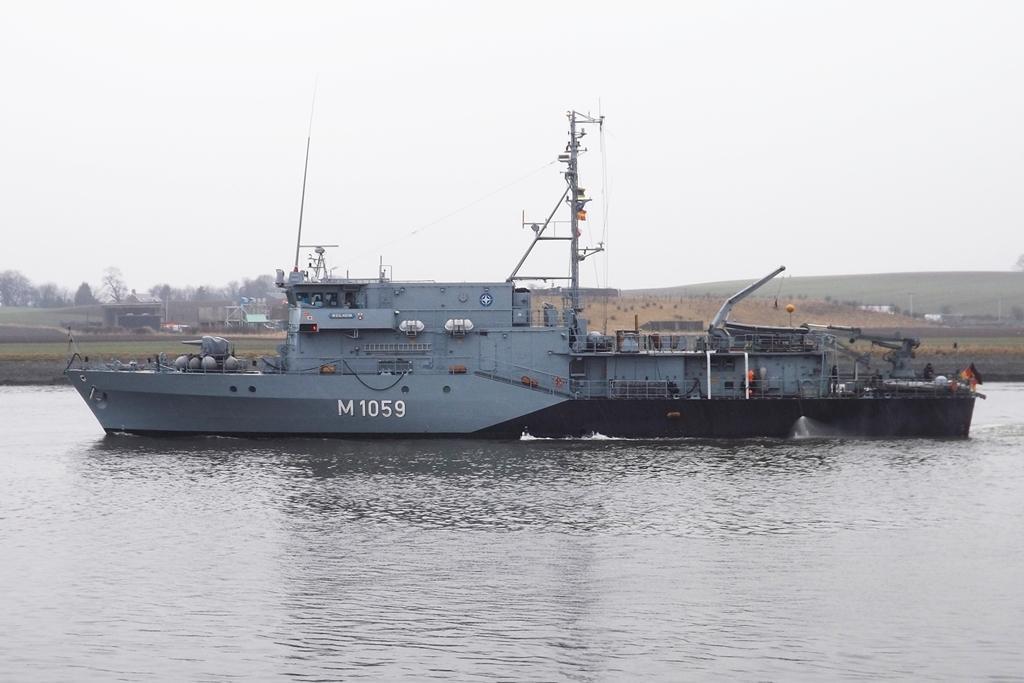Please provide a concise description of this image. In the center of the image we can see one ship on the water. On the ship, we can see some objects. In the background, we can see the sky, trees, grass and a few other objects. 